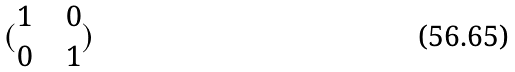Convert formula to latex. <formula><loc_0><loc_0><loc_500><loc_500>( \begin{matrix} 1 & & 0 \\ 0 & & 1 \end{matrix} )</formula> 